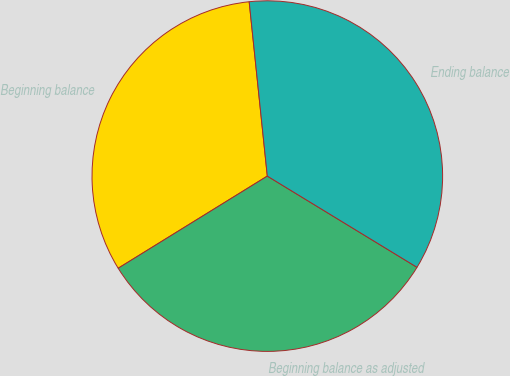Convert chart to OTSL. <chart><loc_0><loc_0><loc_500><loc_500><pie_chart><fcel>Beginning balance<fcel>Beginning balance as adjusted<fcel>Ending balance<nl><fcel>32.16%<fcel>32.48%<fcel>35.36%<nl></chart> 